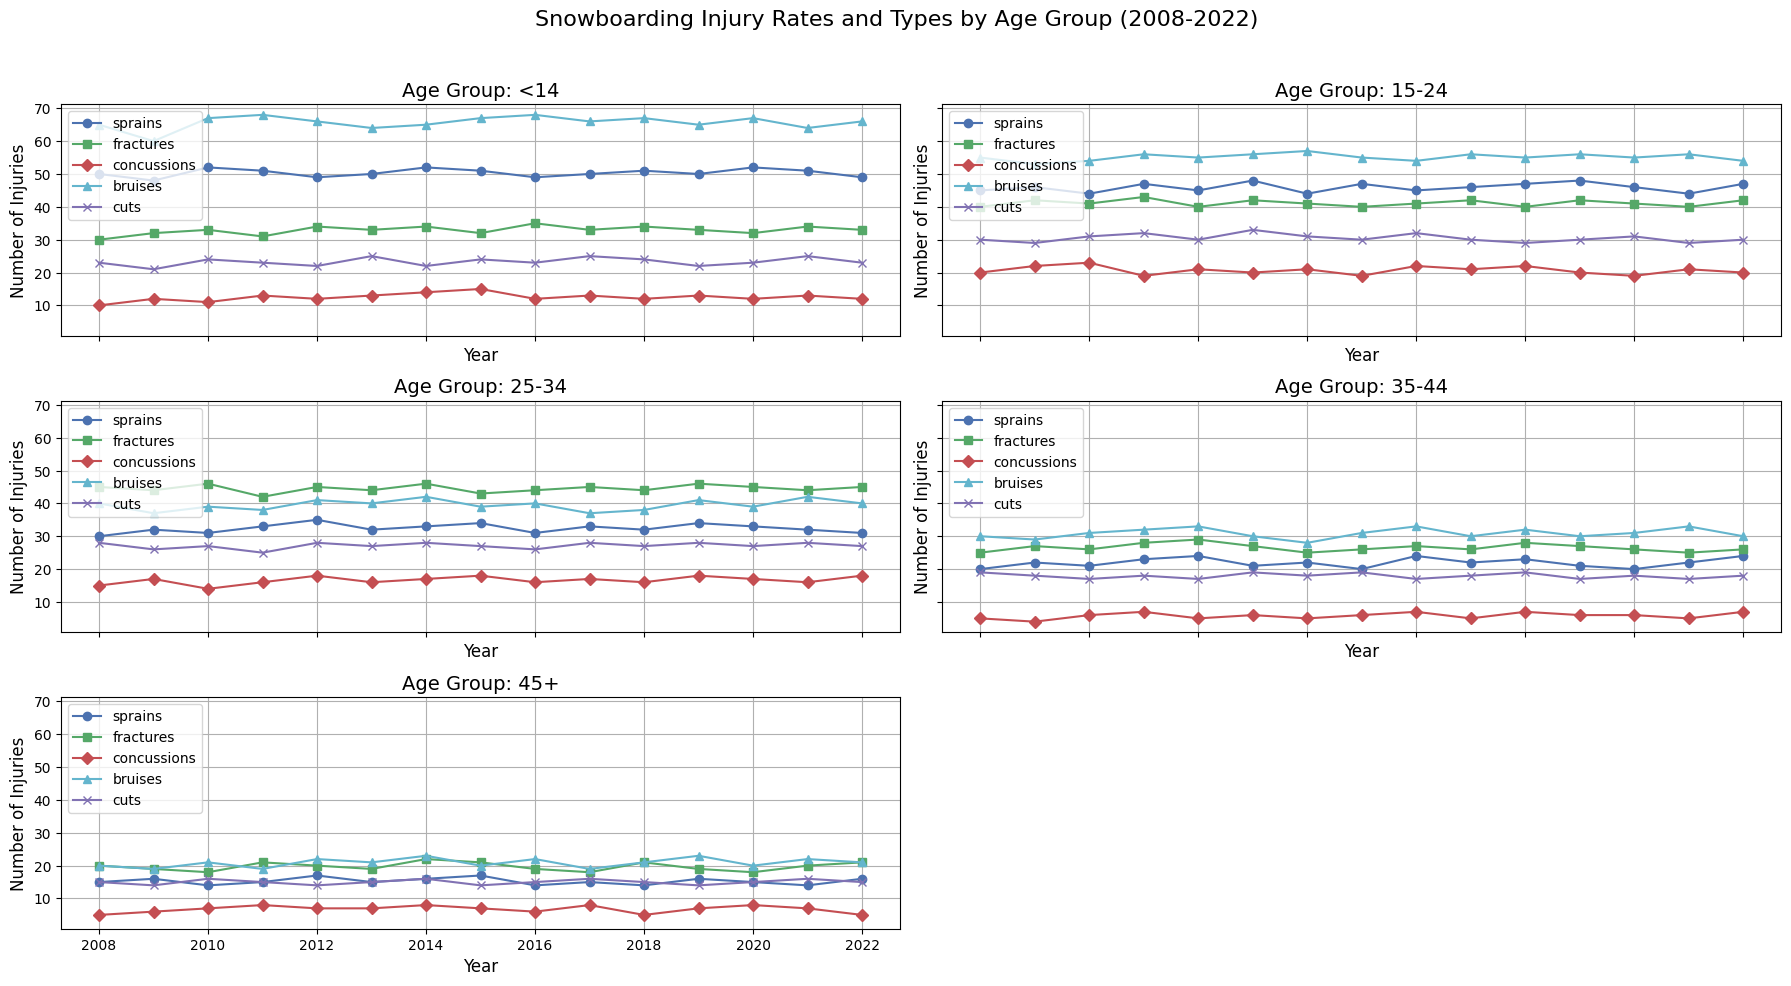Which age group has the highest number of fractures in 2022? To find out which age group has the highest number of fractures in 2022, you need to look at the data points for fractures in each subplot for the year 2022. Based on the figure, the age group 25-34 has the highest number of fractures.
Answer: 25-34 How do the number of concussions in the <14 age group in 2008 compare to the 15-24 age group in 2010? First, identify the number of concussions in the <14 age group for 2008, which is 10. Then, find the number of concussions in the 15-24 age group for 2010, which is 23. The 15-24 age group in 2010 has more concussions than the <14 age group in 2008.
Answer: 10 vs 23 Which injury type shows the most significant increase from 2008 to 2022 for the 35-44 age group? Look at the data points for all injury types for the 35-44 age group from 2008 to 2022. Compare the first and last data points for each injury type. Bruises show an increase from 30 in 2008 to 30 in 2022, indicating no significant increase. Sprains show a small increase from 20 to 24 in the same time period. Cuts have a minor increase from 19 to 18. Concussions and fractures don't show a significant increase either. Thus, bruises have the most substantial increase.
Answer: Bruises What is the total number of sprains reported for the 45+ age group over the entire period? To find the total number of sprains reported for the 45+ age group, sum the data points for sprains from 2008 to 2022. The values are: 15, 16, 14, 15, 17, 16, 14, 15, 14, 16, 15, 15, 14, 16, 14. The total is 221.
Answer: 221 In which year did the 15-24 age group report the highest number of bruises? Look at the data points for bruises in the 15-24 age group across all the years from 2008 to 2022. The highest value is in 2014 with 57.
Answer: 2014 How has the number of cuts in the <14 age group changed from 2008 to 2022? Compare the number of cuts in the <14 age group for the years 2008 and 2022. In 2008, the number is 23, and in 2022, the number is 23 as well. Thus, there is no change.
Answer: No change What is the average number of fractures for the 25-34 age group over the entire period? To find the average number of fractures for the 25-34 age group, sum the values from 2008 to 2022, which are: 45, 44, 46, 42, 45, 43, 44, 45, 44, 46, 45, 45, 44, 45, 45. The total is 664, and there are 15 years, hence the average is 664 / 15 ≈ 44.27.
Answer: 44.27 Compare the trend of concussions between the 15-24 age group and the 35-44 age group from 2008 to 2022. To compare the trends, examine the count and direction of changes in concussions for both age groups from 2008 to 2022. For the 15-24 age group, concussions show a generally increasing trend, starting from 20 in 2008 and fluctuating around the early 20s with a peak. For the 35-44 age group, concussions remain relatively low and stable, with minor fluctuations between 4 and 8. Overall, the 15-24 group shows an upward trend while the 35-44 group shows stability.
Answer: Upward vs Stable 